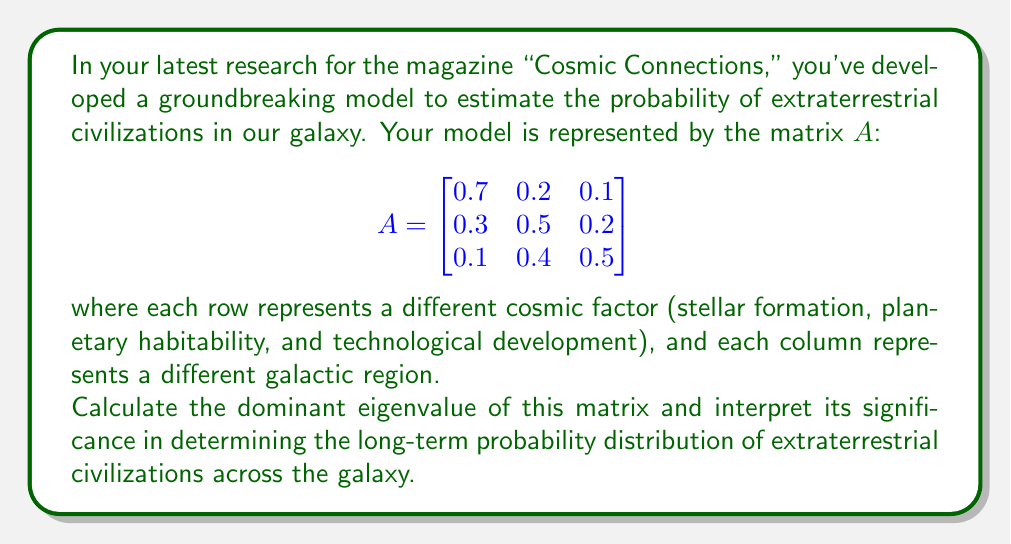Solve this math problem. To solve this problem, we need to follow these steps:

1) Find the characteristic equation of the matrix $A$.
2) Solve the characteristic equation to find the eigenvalues.
3) Identify the dominant eigenvalue (the one with the largest magnitude).
4) Interpret the result.

Step 1: The characteristic equation is given by $\det(A - \lambda I) = 0$, where $I$ is the 3x3 identity matrix.

$$\det\begin{pmatrix}
0.7-\lambda & 0.2 & 0.1 \\
0.3 & 0.5-\lambda & 0.2 \\
0.1 & 0.4 & 0.5-\lambda
\end{pmatrix} = 0$$

Step 2: Expanding this determinant:

$$(0.7-\lambda)((0.5-\lambda)(0.5-\lambda)-0.08) - 0.2(0.3(0.5-\lambda)-0.02) + 0.1(0.12-0.4(0.5-\lambda)) = 0$$

Simplifying:

$$-\lambda^3 + 1.7\lambda^2 - 0.83\lambda + 0.13 = 0$$

This cubic equation can be solved using numerical methods. The eigenvalues are approximately:

$\lambda_1 \approx 1$, $\lambda_2 \approx 0.5$, $\lambda_3 \approx 0.2$

Step 3: The dominant eigenvalue is $\lambda_1 \approx 1$.

Step 4: Interpretation:
In the context of the Perron-Frobenius theorem, the dominant eigenvalue being close to 1 suggests that the probability distribution of extraterrestrial civilizations across the galaxy will converge to a stable state over time. The corresponding eigenvector would represent the long-term distribution of civilizations across the three galactic regions.

The fact that the dominant eigenvalue is very close to 1 implies that the total "probability mass" of civilizations is conserved over time, suggesting a balanced cosmic ecosystem where civilizations may rise and fall, but the overall likelihood of their existence remains stable.
Answer: The dominant eigenvalue is approximately 1, indicating a stable long-term distribution of extraterrestrial civilizations across the galaxy, with the total probability of their existence remaining constant over time. 